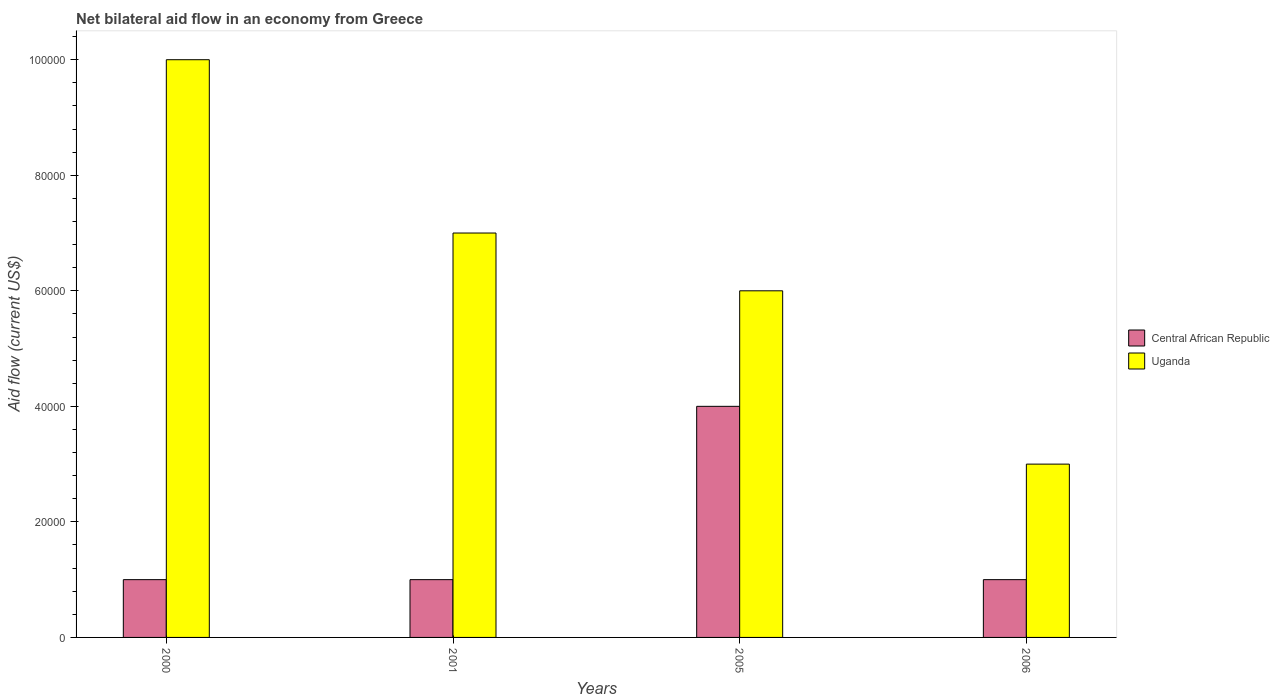Are the number of bars per tick equal to the number of legend labels?
Your answer should be very brief. Yes. How many bars are there on the 3rd tick from the left?
Make the answer very short. 2. How many bars are there on the 4th tick from the right?
Your answer should be very brief. 2. What is the label of the 1st group of bars from the left?
Your answer should be very brief. 2000. What is the net bilateral aid flow in Uganda in 2000?
Your answer should be very brief. 1.00e+05. Across all years, what is the maximum net bilateral aid flow in Central African Republic?
Keep it short and to the point. 4.00e+04. Across all years, what is the minimum net bilateral aid flow in Central African Republic?
Your answer should be very brief. 10000. What is the difference between the net bilateral aid flow in Uganda in 2000 and the net bilateral aid flow in Central African Republic in 2001?
Make the answer very short. 9.00e+04. What is the average net bilateral aid flow in Uganda per year?
Give a very brief answer. 6.50e+04. In the year 2006, what is the difference between the net bilateral aid flow in Central African Republic and net bilateral aid flow in Uganda?
Give a very brief answer. -2.00e+04. In how many years, is the net bilateral aid flow in Central African Republic greater than 40000 US$?
Make the answer very short. 0. What is the ratio of the net bilateral aid flow in Uganda in 2000 to that in 2006?
Offer a very short reply. 3.33. What is the difference between the highest and the second highest net bilateral aid flow in Central African Republic?
Your response must be concise. 3.00e+04. In how many years, is the net bilateral aid flow in Central African Republic greater than the average net bilateral aid flow in Central African Republic taken over all years?
Give a very brief answer. 1. Is the sum of the net bilateral aid flow in Uganda in 2001 and 2006 greater than the maximum net bilateral aid flow in Central African Republic across all years?
Your answer should be very brief. Yes. What does the 2nd bar from the left in 2000 represents?
Give a very brief answer. Uganda. What does the 1st bar from the right in 2006 represents?
Provide a succinct answer. Uganda. How many years are there in the graph?
Offer a terse response. 4. What is the difference between two consecutive major ticks on the Y-axis?
Offer a terse response. 2.00e+04. Are the values on the major ticks of Y-axis written in scientific E-notation?
Make the answer very short. No. Where does the legend appear in the graph?
Offer a very short reply. Center right. What is the title of the graph?
Make the answer very short. Net bilateral aid flow in an economy from Greece. Does "Bahrain" appear as one of the legend labels in the graph?
Make the answer very short. No. What is the label or title of the Y-axis?
Make the answer very short. Aid flow (current US$). What is the Aid flow (current US$) in Uganda in 2006?
Provide a short and direct response. 3.00e+04. Across all years, what is the maximum Aid flow (current US$) in Central African Republic?
Your answer should be compact. 4.00e+04. Across all years, what is the minimum Aid flow (current US$) of Central African Republic?
Give a very brief answer. 10000. Across all years, what is the minimum Aid flow (current US$) of Uganda?
Provide a short and direct response. 3.00e+04. What is the total Aid flow (current US$) in Central African Republic in the graph?
Keep it short and to the point. 7.00e+04. What is the total Aid flow (current US$) of Uganda in the graph?
Provide a short and direct response. 2.60e+05. What is the difference between the Aid flow (current US$) of Central African Republic in 2000 and that in 2001?
Offer a very short reply. 0. What is the difference between the Aid flow (current US$) in Central African Republic in 2000 and that in 2005?
Your response must be concise. -3.00e+04. What is the difference between the Aid flow (current US$) in Uganda in 2000 and that in 2005?
Your answer should be compact. 4.00e+04. What is the difference between the Aid flow (current US$) of Central African Republic in 2000 and that in 2006?
Provide a succinct answer. 0. What is the difference between the Aid flow (current US$) in Central African Republic in 2001 and that in 2005?
Ensure brevity in your answer.  -3.00e+04. What is the difference between the Aid flow (current US$) in Uganda in 2001 and that in 2005?
Make the answer very short. 10000. What is the difference between the Aid flow (current US$) in Central African Republic in 2001 and that in 2006?
Provide a succinct answer. 0. What is the difference between the Aid flow (current US$) in Central African Republic in 2000 and the Aid flow (current US$) in Uganda in 2006?
Keep it short and to the point. -2.00e+04. What is the average Aid flow (current US$) of Central African Republic per year?
Keep it short and to the point. 1.75e+04. What is the average Aid flow (current US$) in Uganda per year?
Your answer should be very brief. 6.50e+04. In the year 2005, what is the difference between the Aid flow (current US$) in Central African Republic and Aid flow (current US$) in Uganda?
Make the answer very short. -2.00e+04. In the year 2006, what is the difference between the Aid flow (current US$) in Central African Republic and Aid flow (current US$) in Uganda?
Offer a terse response. -2.00e+04. What is the ratio of the Aid flow (current US$) of Uganda in 2000 to that in 2001?
Provide a succinct answer. 1.43. What is the ratio of the Aid flow (current US$) of Uganda in 2000 to that in 2005?
Make the answer very short. 1.67. What is the ratio of the Aid flow (current US$) of Central African Republic in 2001 to that in 2005?
Ensure brevity in your answer.  0.25. What is the ratio of the Aid flow (current US$) of Uganda in 2001 to that in 2006?
Your answer should be compact. 2.33. What is the ratio of the Aid flow (current US$) in Central African Republic in 2005 to that in 2006?
Give a very brief answer. 4. What is the ratio of the Aid flow (current US$) in Uganda in 2005 to that in 2006?
Offer a terse response. 2. What is the difference between the highest and the second highest Aid flow (current US$) of Central African Republic?
Provide a short and direct response. 3.00e+04. What is the difference between the highest and the second highest Aid flow (current US$) in Uganda?
Offer a very short reply. 3.00e+04. 